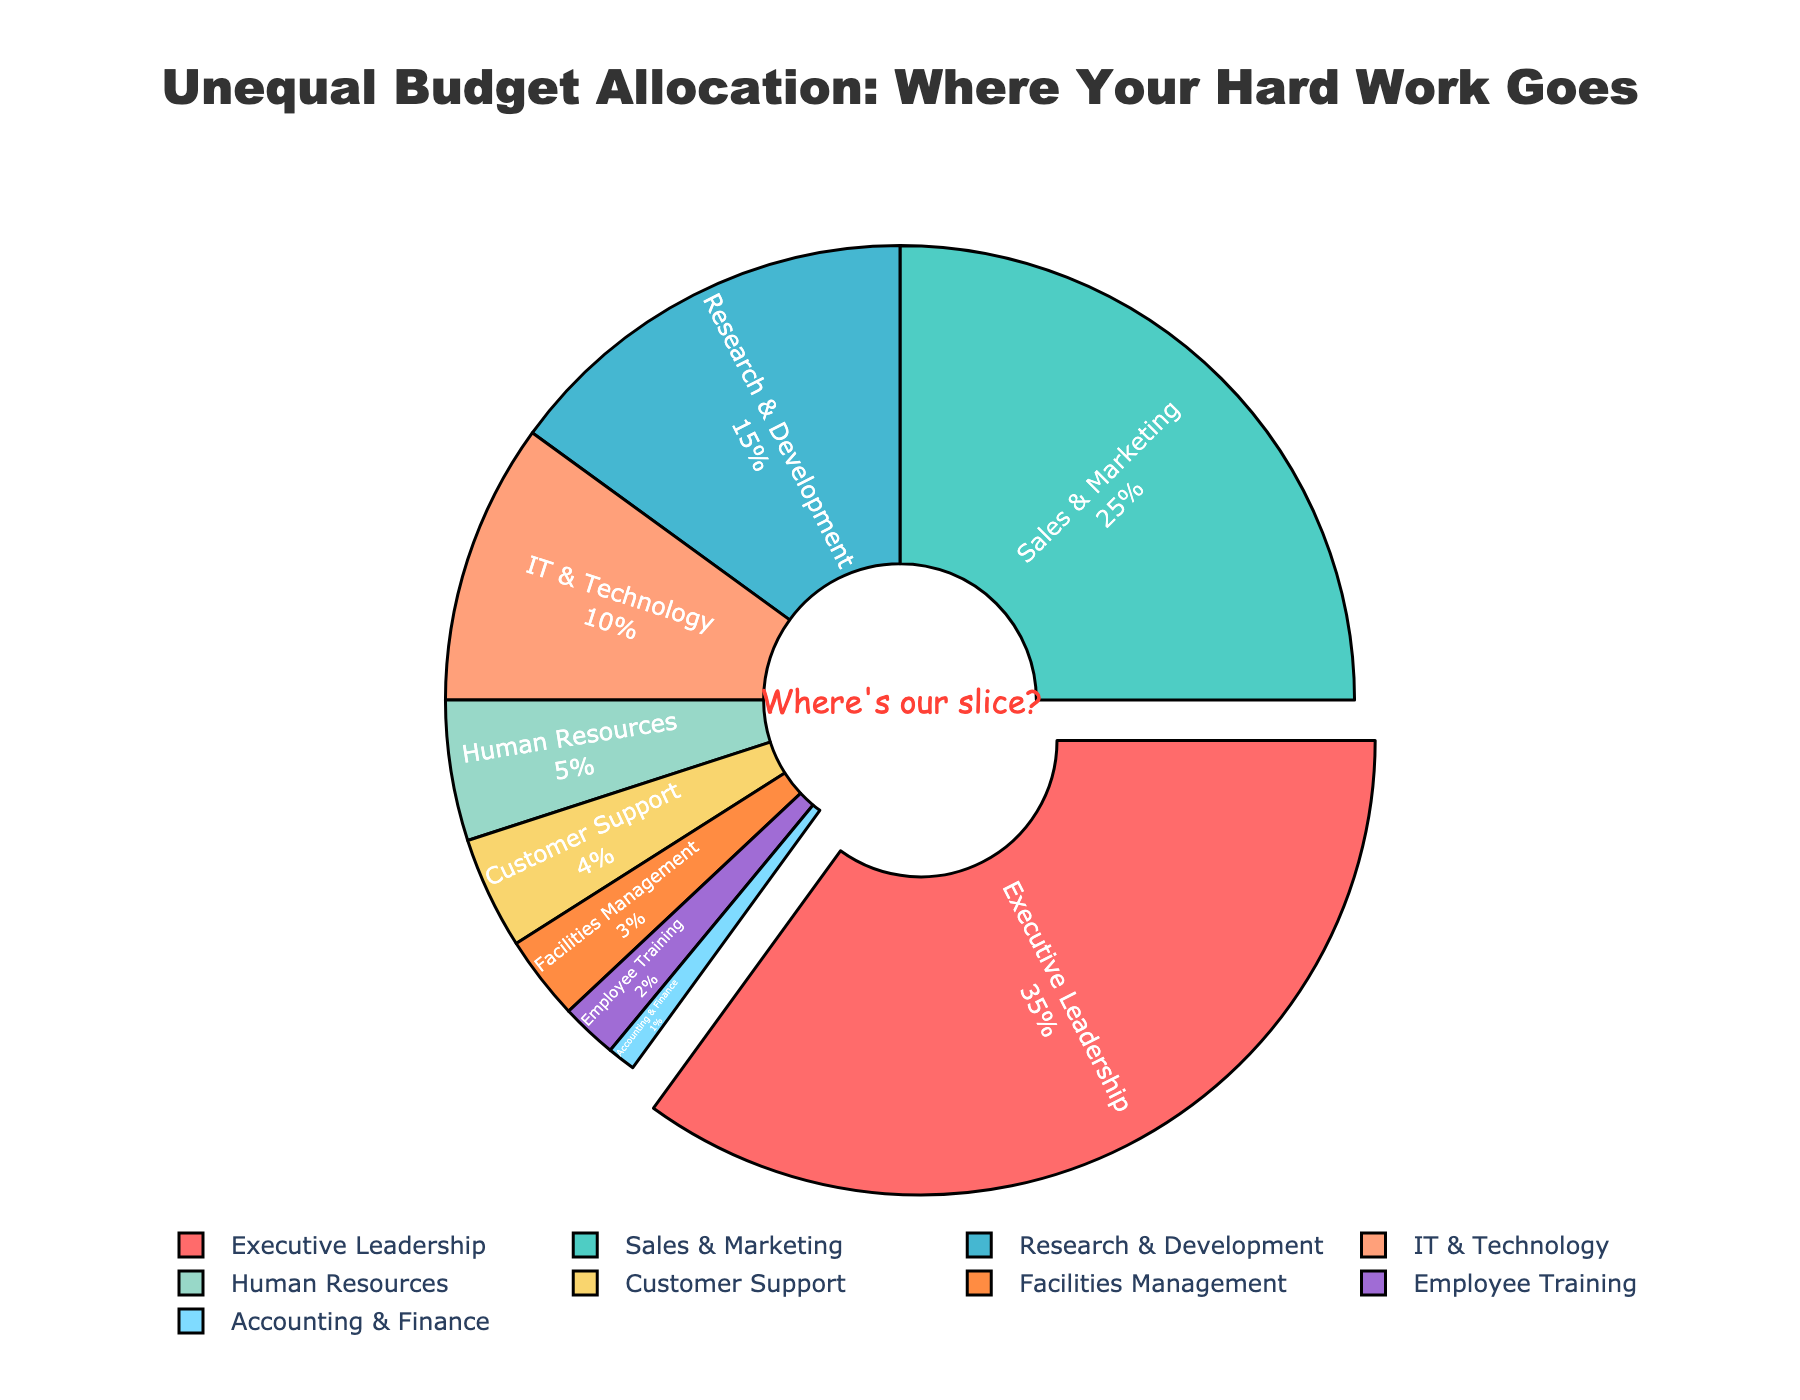What's the total budget allocation for departments excluding Executive Leadership? The budget allocation for departments excluding Executive Leadership is the sum of all other departments. Add: 25 (Sales & Marketing) + 15 (Research & Development) + 10 (IT & Technology) + 5 (Human Resources) + 4 (Customer Support) + 3 (Facilities Management) + 2 (Employee Training) + 1 (Accounting & Finance) = 65%.
Answer: 65% Which department receives a larger budget allocation, Sales & Marketing or Research & Development? Compare the budget allocations for Sales & Marketing (25%) and Research & Development (15%). Since 25% is greater than 15%, Sales & Marketing receives a larger budget allocation.
Answer: Sales & Marketing By how much does the budget allocation for Executive Leadership exceed the combined allocation of IT & Technology and Human Resources? The budget allocation for Executive Leadership (35%) exceeds the combined allocations of IT & Technology (10%) and Human Resources (5%). Calculate the difference: 35% - (10% + 5%) = 35% - 15% = 20%.
Answer: 20% Which is the smallest budget allocation, and for which department is it? Look at the smallest percentage on the pie chart. The smallest allocation is 1%, which is for the Accounting & Finance department.
Answer: Accounting & Finance What proportion of the budget is allocated to Customer Support relative to Facilities Management? Compare the percentages allocated to Customer Support (4%) and Facilities Management (3%). Customer Support has 4/3 times the allocation of Facilities Management.
Answer: 4/3 Which department has the most prominent visual pull-out? The department with the highest budget allocation is Executive Leadership, and it is visually emphasized by being pulled out.
Answer: Executive Leadership If the budget for Employee Training was doubled, what would it become? The original budget for Employee Training is 2%. Doubling it would make it 2% * 2 = 4%.
Answer: 4% What's the visual significance of the text in the center of the pie chart? The text in the center of the pie chart saying "Where's our slice?" highlights that the pie chart is meant to emphasize inequalities and possible unfairness in budget distribution.
Answer: Emphasizing inequalities How does the combined budget allocation for Facilities Management and Customer Support compare to Research & Development? Combine the budgets for Facilities Management (3%) and Customer Support (4%), giving a total of 3% + 4% = 7%. Research & Development allocated 15%, so Research & Development has a higher allocation.
Answer: Research & Development What's the difference in the budget allocation between Sales & Marketing and IT & Technology? Subtract the budget allocation of IT & Technology (10%) from that of Sales & Marketing (25%): 25% - 10% = 15%.
Answer: 15% 